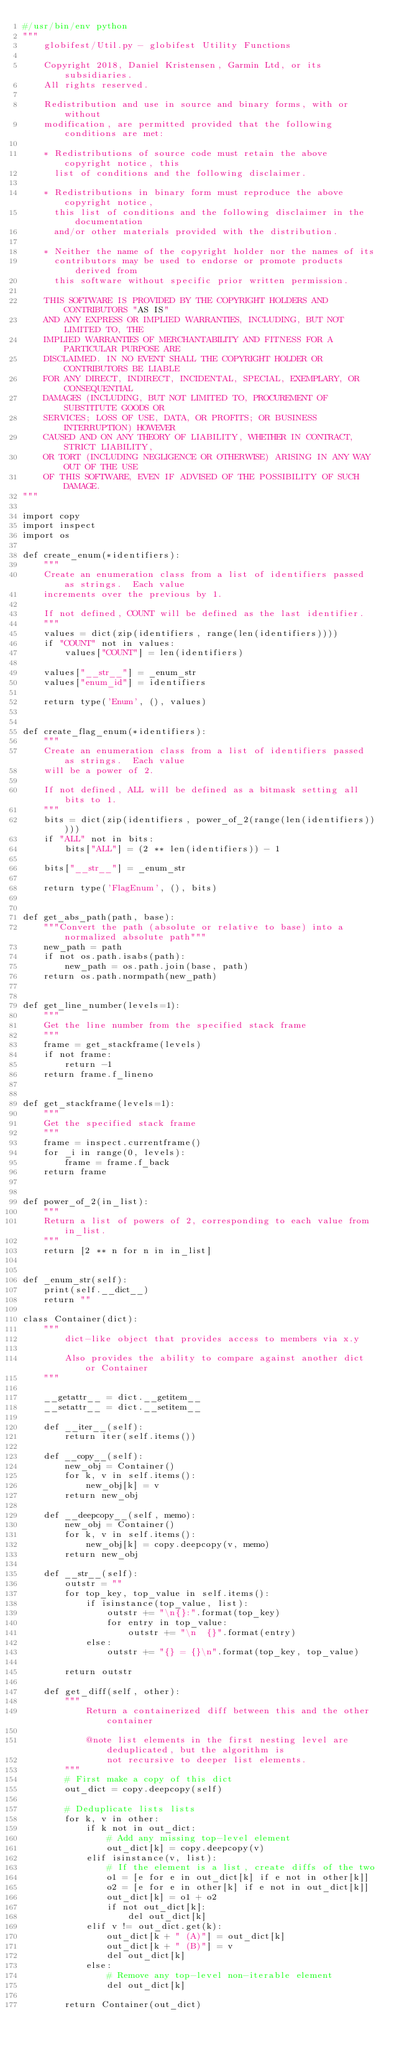Convert code to text. <code><loc_0><loc_0><loc_500><loc_500><_Python_>#/usr/bin/env python
"""
    globifest/Util.py - globifest Utility Functions

    Copyright 2018, Daniel Kristensen, Garmin Ltd, or its subsidiaries.
    All rights reserved.

    Redistribution and use in source and binary forms, with or without
    modification, are permitted provided that the following conditions are met:

    * Redistributions of source code must retain the above copyright notice, this
      list of conditions and the following disclaimer.

    * Redistributions in binary form must reproduce the above copyright notice,
      this list of conditions and the following disclaimer in the documentation
      and/or other materials provided with the distribution.

    * Neither the name of the copyright holder nor the names of its
      contributors may be used to endorse or promote products derived from
      this software without specific prior written permission.

    THIS SOFTWARE IS PROVIDED BY THE COPYRIGHT HOLDERS AND CONTRIBUTORS "AS IS"
    AND ANY EXPRESS OR IMPLIED WARRANTIES, INCLUDING, BUT NOT LIMITED TO, THE
    IMPLIED WARRANTIES OF MERCHANTABILITY AND FITNESS FOR A PARTICULAR PURPOSE ARE
    DISCLAIMED. IN NO EVENT SHALL THE COPYRIGHT HOLDER OR CONTRIBUTORS BE LIABLE
    FOR ANY DIRECT, INDIRECT, INCIDENTAL, SPECIAL, EXEMPLARY, OR CONSEQUENTIAL
    DAMAGES (INCLUDING, BUT NOT LIMITED TO, PROCUREMENT OF SUBSTITUTE GOODS OR
    SERVICES; LOSS OF USE, DATA, OR PROFITS; OR BUSINESS INTERRUPTION) HOWEVER
    CAUSED AND ON ANY THEORY OF LIABILITY, WHETHER IN CONTRACT, STRICT LIABILITY,
    OR TORT (INCLUDING NEGLIGENCE OR OTHERWISE) ARISING IN ANY WAY OUT OF THE USE
    OF THIS SOFTWARE, EVEN IF ADVISED OF THE POSSIBILITY OF SUCH DAMAGE.
"""

import copy
import inspect
import os

def create_enum(*identifiers):
    """
    Create an enumeration class from a list of identifiers passed as strings.  Each value
    increments over the previous by 1.

    If not defined, COUNT will be defined as the last identifier.
    """
    values = dict(zip(identifiers, range(len(identifiers))))
    if "COUNT" not in values:
        values["COUNT"] = len(identifiers)

    values["__str__"] = _enum_str
    values["enum_id"] = identifiers

    return type('Enum', (), values)


def create_flag_enum(*identifiers):
    """
    Create an enumeration class from a list of identifiers passed as strings.  Each value
    will be a power of 2.

    If not defined, ALL will be defined as a bitmask setting all bits to 1.
    """
    bits = dict(zip(identifiers, power_of_2(range(len(identifiers)))))
    if "ALL" not in bits:
        bits["ALL"] = (2 ** len(identifiers)) - 1

    bits["__str__"] = _enum_str

    return type('FlagEnum', (), bits)


def get_abs_path(path, base):
    """Convert the path (absolute or relative to base) into a normalized absolute path"""
    new_path = path
    if not os.path.isabs(path):
        new_path = os.path.join(base, path)
    return os.path.normpath(new_path)


def get_line_number(levels=1):
    """
    Get the line number from the specified stack frame
    """
    frame = get_stackframe(levels)
    if not frame:
        return -1
    return frame.f_lineno


def get_stackframe(levels=1):
    """
    Get the specified stack frame
    """
    frame = inspect.currentframe()
    for _i in range(0, levels):
        frame = frame.f_back
    return frame


def power_of_2(in_list):
    """
    Return a list of powers of 2, corresponding to each value from in_list.
    """
    return [2 ** n for n in in_list]


def _enum_str(self):
    print(self.__dict__)
    return ""

class Container(dict):
    """
        dict-like object that provides access to members via x.y

        Also provides the ability to compare against another dict or Container
    """

    __getattr__ = dict.__getitem__
    __setattr__ = dict.__setitem__

    def __iter__(self):
        return iter(self.items())

    def __copy__(self):
        new_obj = Container()
        for k, v in self.items():
            new_obj[k] = v
        return new_obj

    def __deepcopy__(self, memo):
        new_obj = Container()
        for k, v in self.items():
            new_obj[k] = copy.deepcopy(v, memo)
        return new_obj

    def __str__(self):
        outstr = ""
        for top_key, top_value in self.items():
            if isinstance(top_value, list):
                outstr += "\n{}:".format(top_key)
                for entry in top_value:
                    outstr += "\n  {}".format(entry)
            else:
                outstr += "{} = {}\n".format(top_key, top_value)

        return outstr

    def get_diff(self, other):
        """
            Return a containerized diff between this and the other container

            @note list elements in the first nesting level are deduplicated, but the algorithm is
                not recursive to deeper list elements.
        """
        # First make a copy of this dict
        out_dict = copy.deepcopy(self)

        # Deduplicate lists lists
        for k, v in other:
            if k not in out_dict:
                # Add any missing top-level element
                out_dict[k] = copy.deepcopy(v)
            elif isinstance(v, list):
                # If the element is a list, create diffs of the two
                o1 = [e for e in out_dict[k] if e not in other[k]]
                o2 = [e for e in other[k] if e not in out_dict[k]]
                out_dict[k] = o1 + o2
                if not out_dict[k]:
                    del out_dict[k]
            elif v != out_dict.get(k):
                out_dict[k + " (A)"] = out_dict[k]
                out_dict[k + " (B)"] = v
                del out_dict[k]
            else:
                # Remove any top-level non-iterable element
                del out_dict[k]

        return Container(out_dict)
</code> 